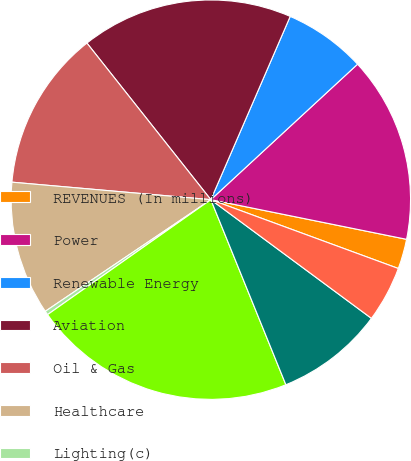Convert chart. <chart><loc_0><loc_0><loc_500><loc_500><pie_chart><fcel>REVENUES (In millions)<fcel>Power<fcel>Renewable Energy<fcel>Aviation<fcel>Oil & Gas<fcel>Healthcare<fcel>Lighting(c)<fcel>Total industrial segment<fcel>Capital<fcel>Corporate items and<nl><fcel>2.42%<fcel>15.05%<fcel>6.63%<fcel>17.16%<fcel>12.95%<fcel>10.84%<fcel>0.32%<fcel>21.37%<fcel>8.74%<fcel>4.53%<nl></chart> 